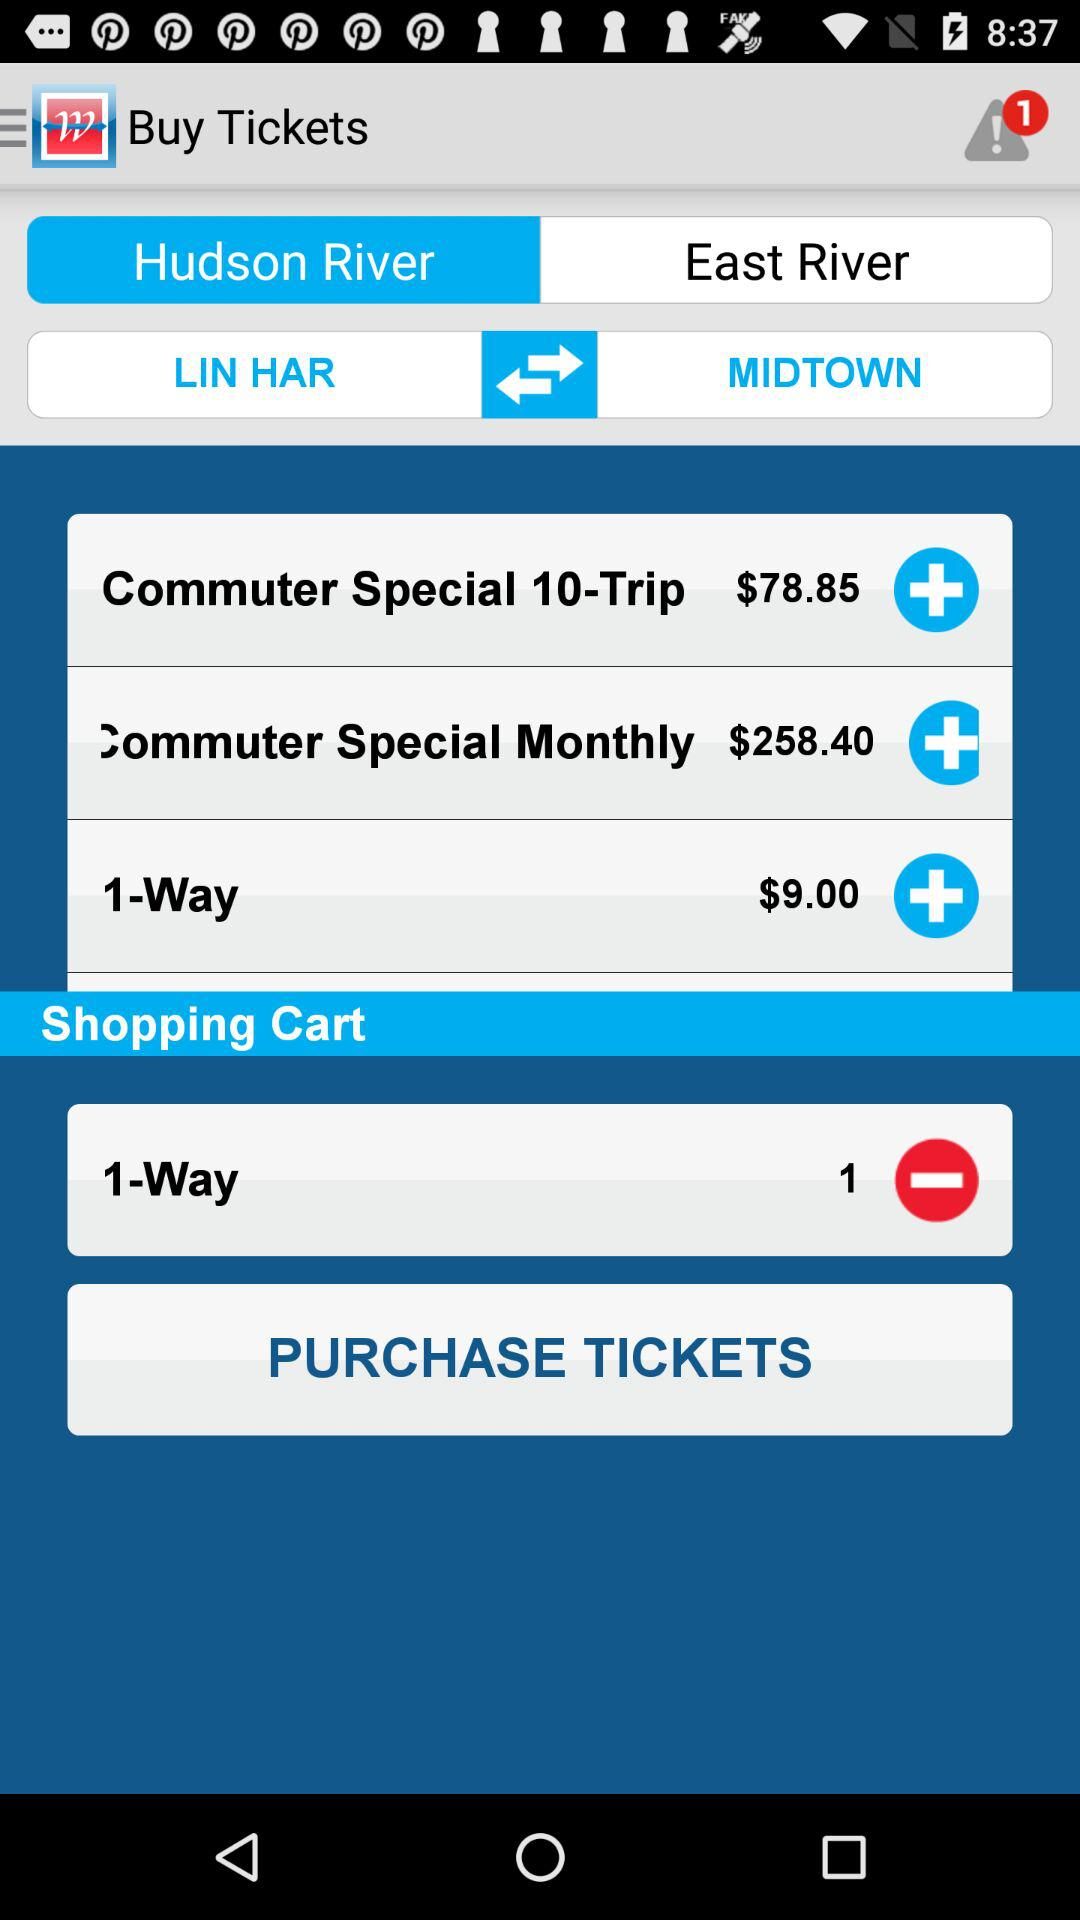What is the fare for the "Commuter Special 10-Trip"? The fare is $78.85. 